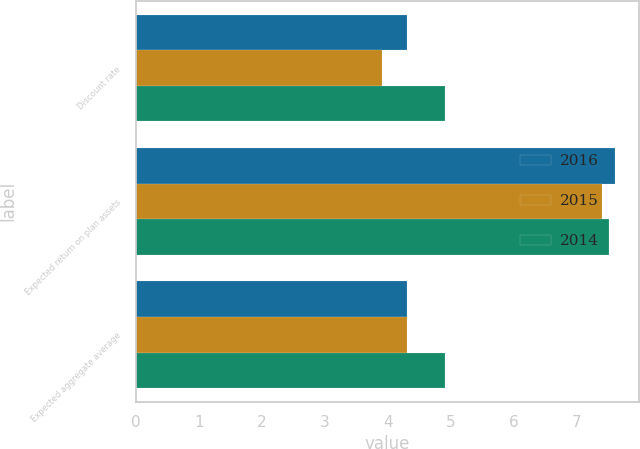Convert chart to OTSL. <chart><loc_0><loc_0><loc_500><loc_500><stacked_bar_chart><ecel><fcel>Discount rate<fcel>Expected return on plan assets<fcel>Expected aggregate average<nl><fcel>2016<fcel>4.3<fcel>7.6<fcel>4.3<nl><fcel>2015<fcel>3.9<fcel>7.4<fcel>4.3<nl><fcel>2014<fcel>4.9<fcel>7.5<fcel>4.9<nl></chart> 